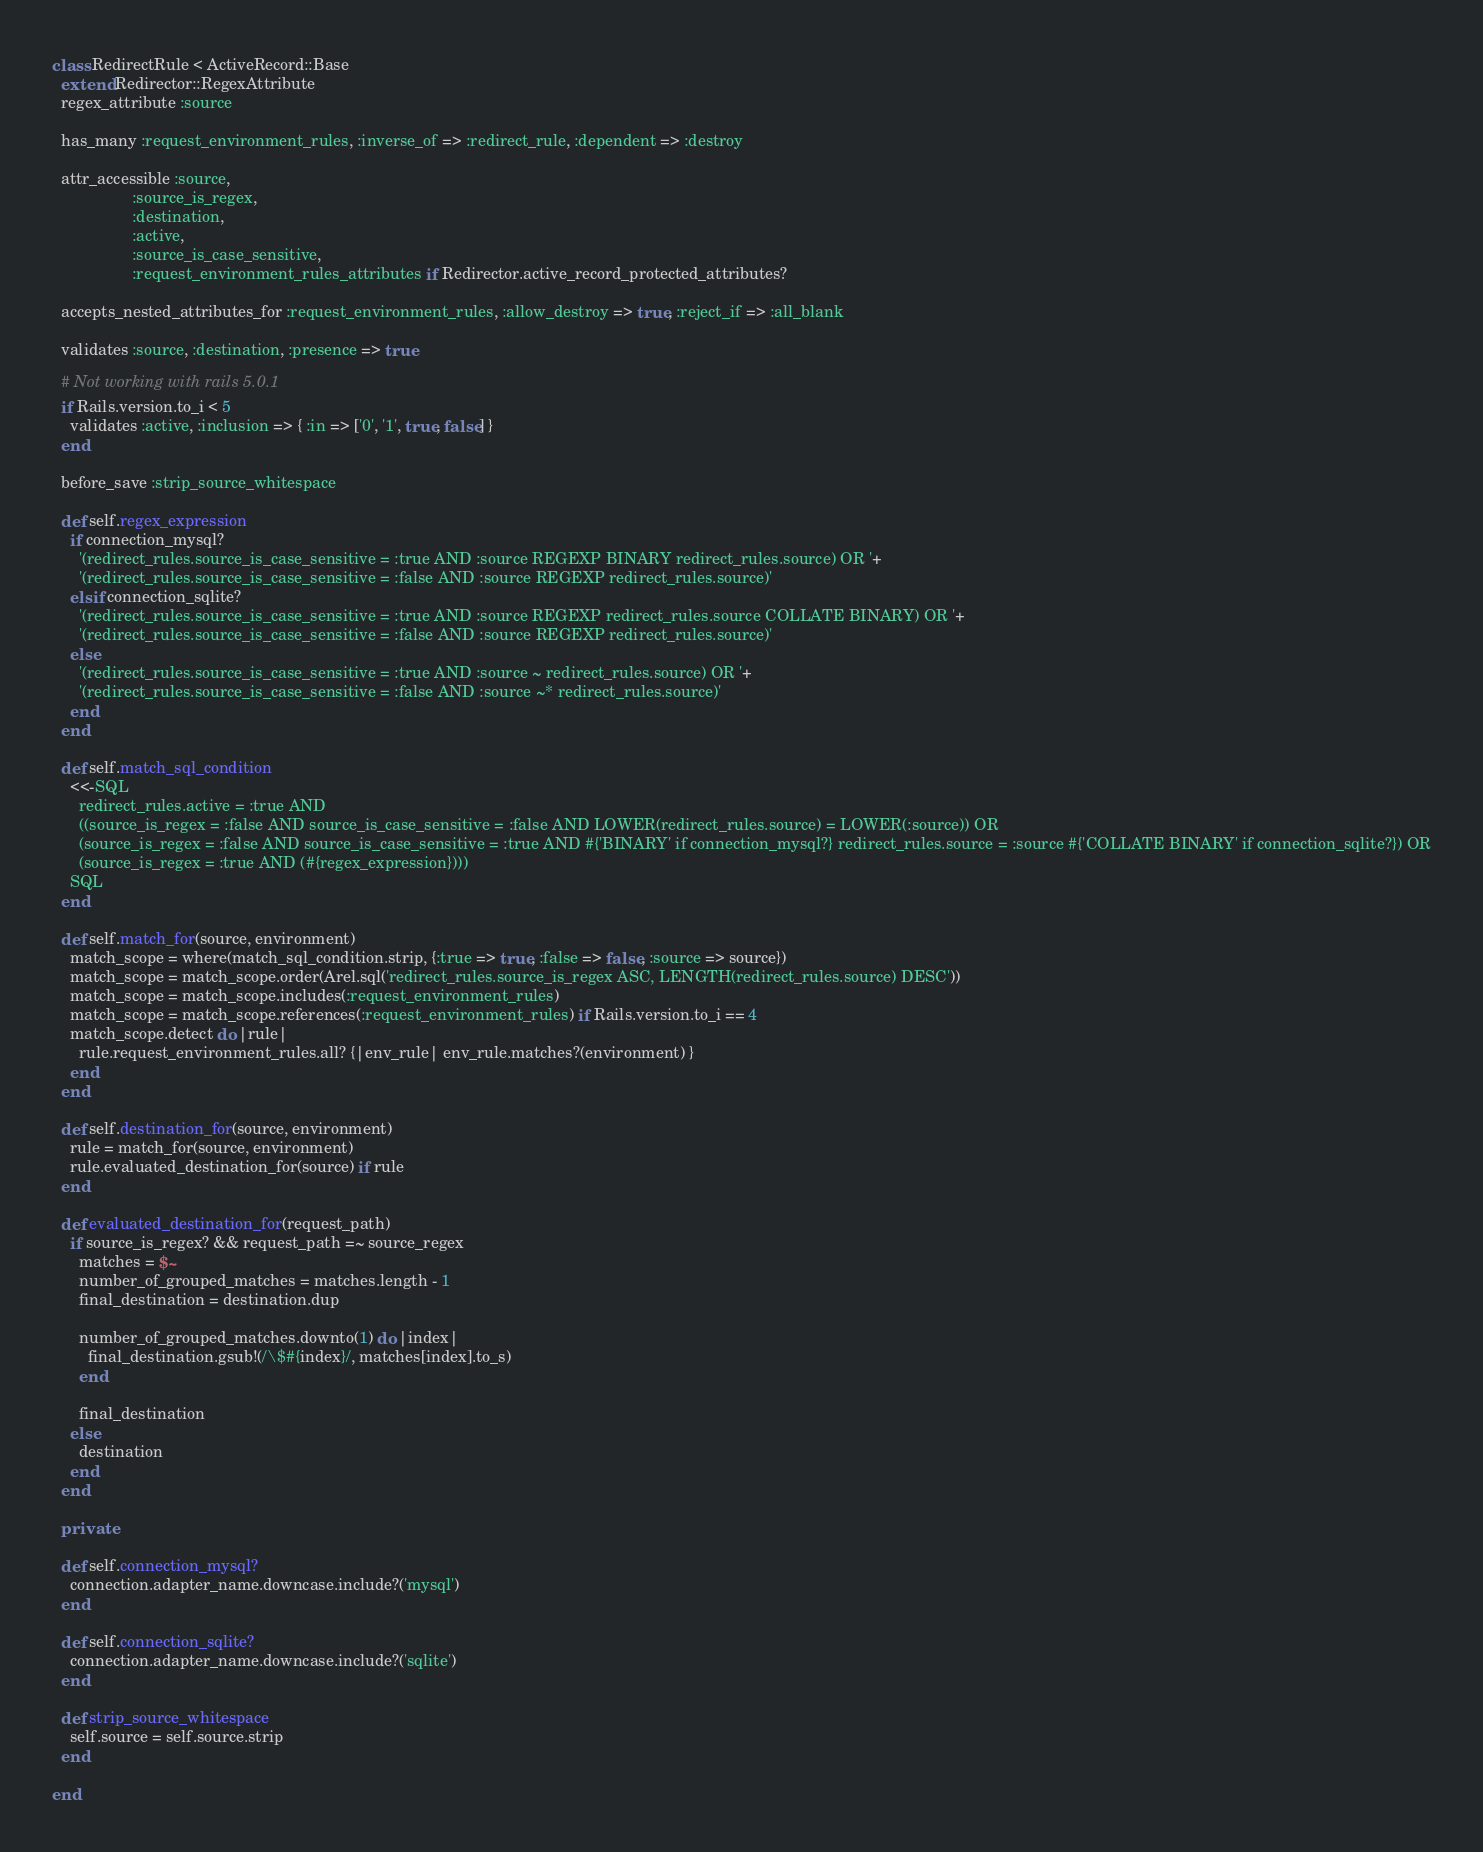<code> <loc_0><loc_0><loc_500><loc_500><_Ruby_>class RedirectRule < ActiveRecord::Base
  extend Redirector::RegexAttribute
  regex_attribute :source

  has_many :request_environment_rules, :inverse_of => :redirect_rule, :dependent => :destroy

  attr_accessible :source,
                  :source_is_regex,
                  :destination,
                  :active,
                  :source_is_case_sensitive,
                  :request_environment_rules_attributes if Redirector.active_record_protected_attributes?

  accepts_nested_attributes_for :request_environment_rules, :allow_destroy => true, :reject_if => :all_blank

  validates :source, :destination, :presence => true

  # Not working with rails 5.0.1
  if Rails.version.to_i < 5
    validates :active, :inclusion => { :in => ['0', '1', true, false] }
  end

  before_save :strip_source_whitespace

  def self.regex_expression
    if connection_mysql?
      '(redirect_rules.source_is_case_sensitive = :true AND :source REGEXP BINARY redirect_rules.source) OR '+
      '(redirect_rules.source_is_case_sensitive = :false AND :source REGEXP redirect_rules.source)'
    elsif connection_sqlite?
      '(redirect_rules.source_is_case_sensitive = :true AND :source REGEXP redirect_rules.source COLLATE BINARY) OR '+
      '(redirect_rules.source_is_case_sensitive = :false AND :source REGEXP redirect_rules.source)'
    else
      '(redirect_rules.source_is_case_sensitive = :true AND :source ~ redirect_rules.source) OR '+
      '(redirect_rules.source_is_case_sensitive = :false AND :source ~* redirect_rules.source)'
    end
  end

  def self.match_sql_condition
    <<-SQL
      redirect_rules.active = :true AND
      ((source_is_regex = :false AND source_is_case_sensitive = :false AND LOWER(redirect_rules.source) = LOWER(:source)) OR
      (source_is_regex = :false AND source_is_case_sensitive = :true AND #{'BINARY' if connection_mysql?} redirect_rules.source = :source #{'COLLATE BINARY' if connection_sqlite?}) OR
      (source_is_regex = :true AND (#{regex_expression})))
    SQL
  end

  def self.match_for(source, environment)
    match_scope = where(match_sql_condition.strip, {:true => true, :false => false, :source => source})
    match_scope = match_scope.order(Arel.sql('redirect_rules.source_is_regex ASC, LENGTH(redirect_rules.source) DESC'))
    match_scope = match_scope.includes(:request_environment_rules)
    match_scope = match_scope.references(:request_environment_rules) if Rails.version.to_i == 4
    match_scope.detect do |rule|
      rule.request_environment_rules.all? {|env_rule| env_rule.matches?(environment) }
    end
  end

  def self.destination_for(source, environment)
    rule = match_for(source, environment)
    rule.evaluated_destination_for(source) if rule
  end

  def evaluated_destination_for(request_path)
    if source_is_regex? && request_path =~ source_regex
      matches = $~
      number_of_grouped_matches = matches.length - 1
      final_destination = destination.dup

      number_of_grouped_matches.downto(1) do |index|
        final_destination.gsub!(/\$#{index}/, matches[index].to_s)
      end

      final_destination
    else
      destination
    end
  end

  private

  def self.connection_mysql?
    connection.adapter_name.downcase.include?('mysql')
  end

  def self.connection_sqlite?
    connection.adapter_name.downcase.include?('sqlite')
  end

  def strip_source_whitespace
    self.source = self.source.strip
  end

end
</code> 